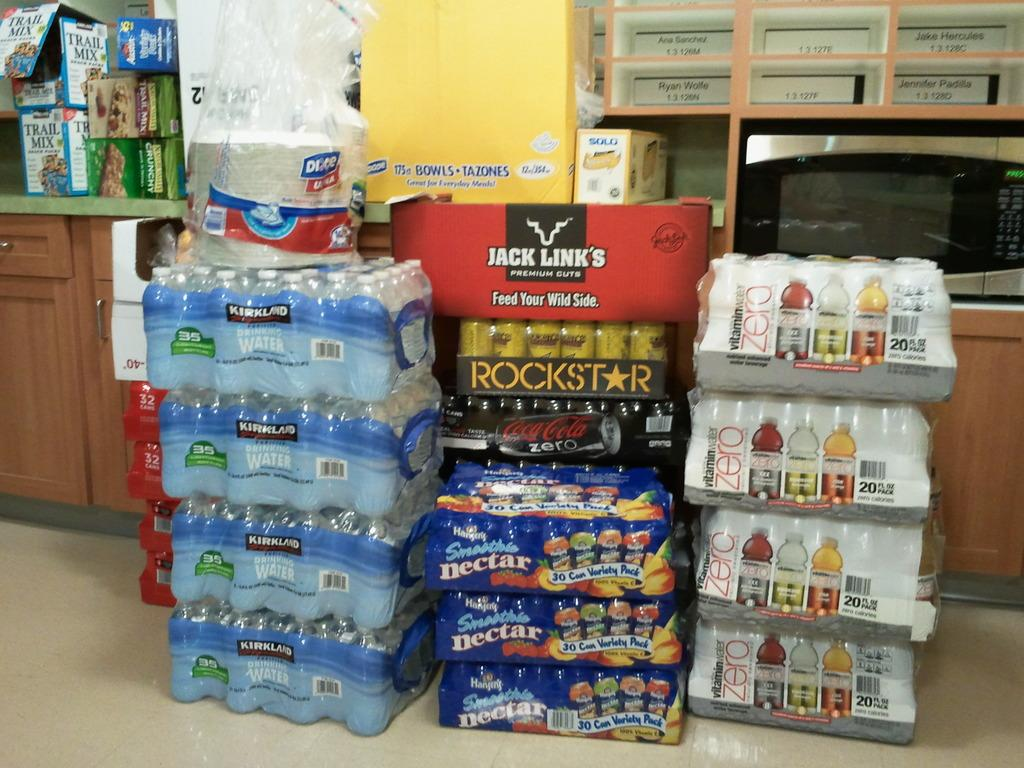<image>
Relay a brief, clear account of the picture shown. Stacks of cases of drinks and snacks including Kirkland water, Rockstar energy drink, Jack Links, and more. 